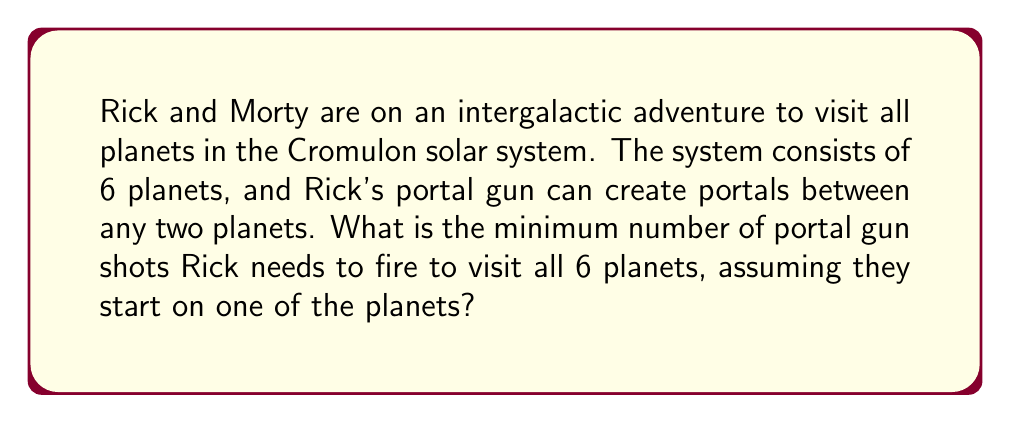Help me with this question. To solve this problem, we can use concepts from graph theory, specifically the idea of a minimum spanning tree.

1) First, let's model the solar system as a complete graph:
   - Each planet is a vertex
   - Each possible portal connection is an edge

2) The number of vertices (planets) is 6.

3) In a complete graph, the number of edges is given by the formula:
   $$ \text{Number of edges} = \frac{n(n-1)}{2} $$
   where $n$ is the number of vertices.

4) In this case:
   $$ \text{Number of edges} = \frac{6(6-1)}{2} = \frac{6 \times 5}{2} = 15 $$

5) To visit all planets with the minimum number of portal shots, we need to find a minimum spanning tree of this graph.

6) A tree is a connected graph with no cycles. A spanning tree includes all vertices of the original graph.

7) For any tree, the number of edges is always one less than the number of vertices. This is because each new vertex (except the first) requires exactly one new edge to connect it to the existing tree.

8) Therefore, the minimum number of portal gun shots needed is:
   $$ \text{Minimum shots} = \text{Number of planets} - 1 = 6 - 1 = 5 $$

This solution ensures that Rick and Morty can reach all planets while using the fewest possible portal gun shots.
Answer: The minimum number of portal gun shots needed is $5$. 